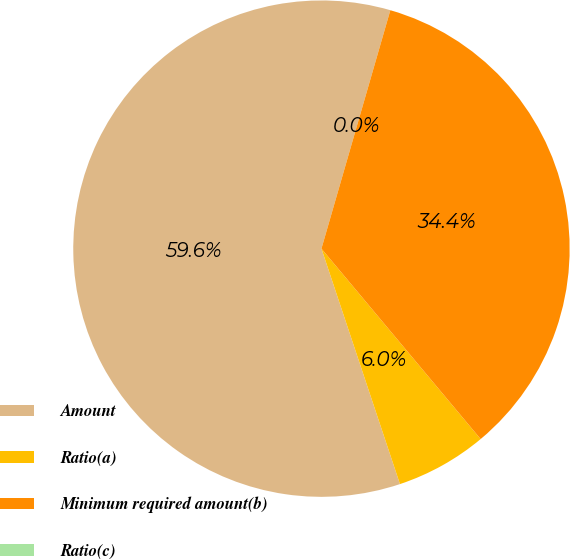Convert chart. <chart><loc_0><loc_0><loc_500><loc_500><pie_chart><fcel>Amount<fcel>Ratio(a)<fcel>Minimum required amount(b)<fcel>Ratio(c)<nl><fcel>59.6%<fcel>5.96%<fcel>34.44%<fcel>0.0%<nl></chart> 